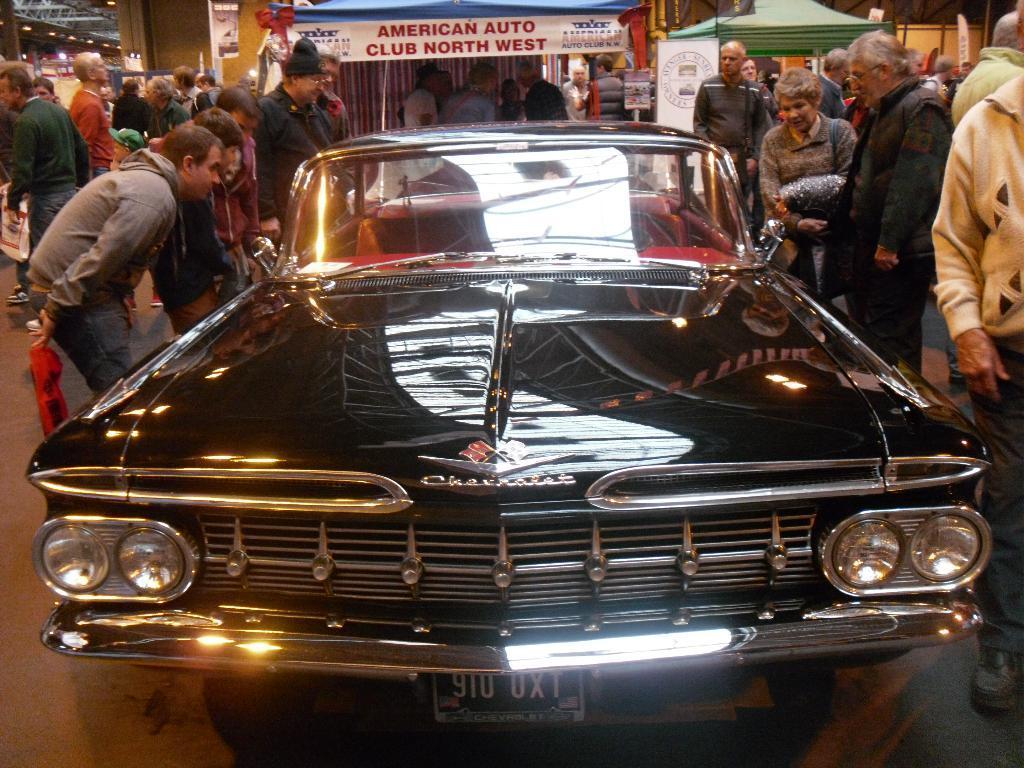How would you summarize this image in a sentence or two? In the picture I can see a black color car and people standing on the ground. In the background I can see a banners which has something written on them and some other objects. 